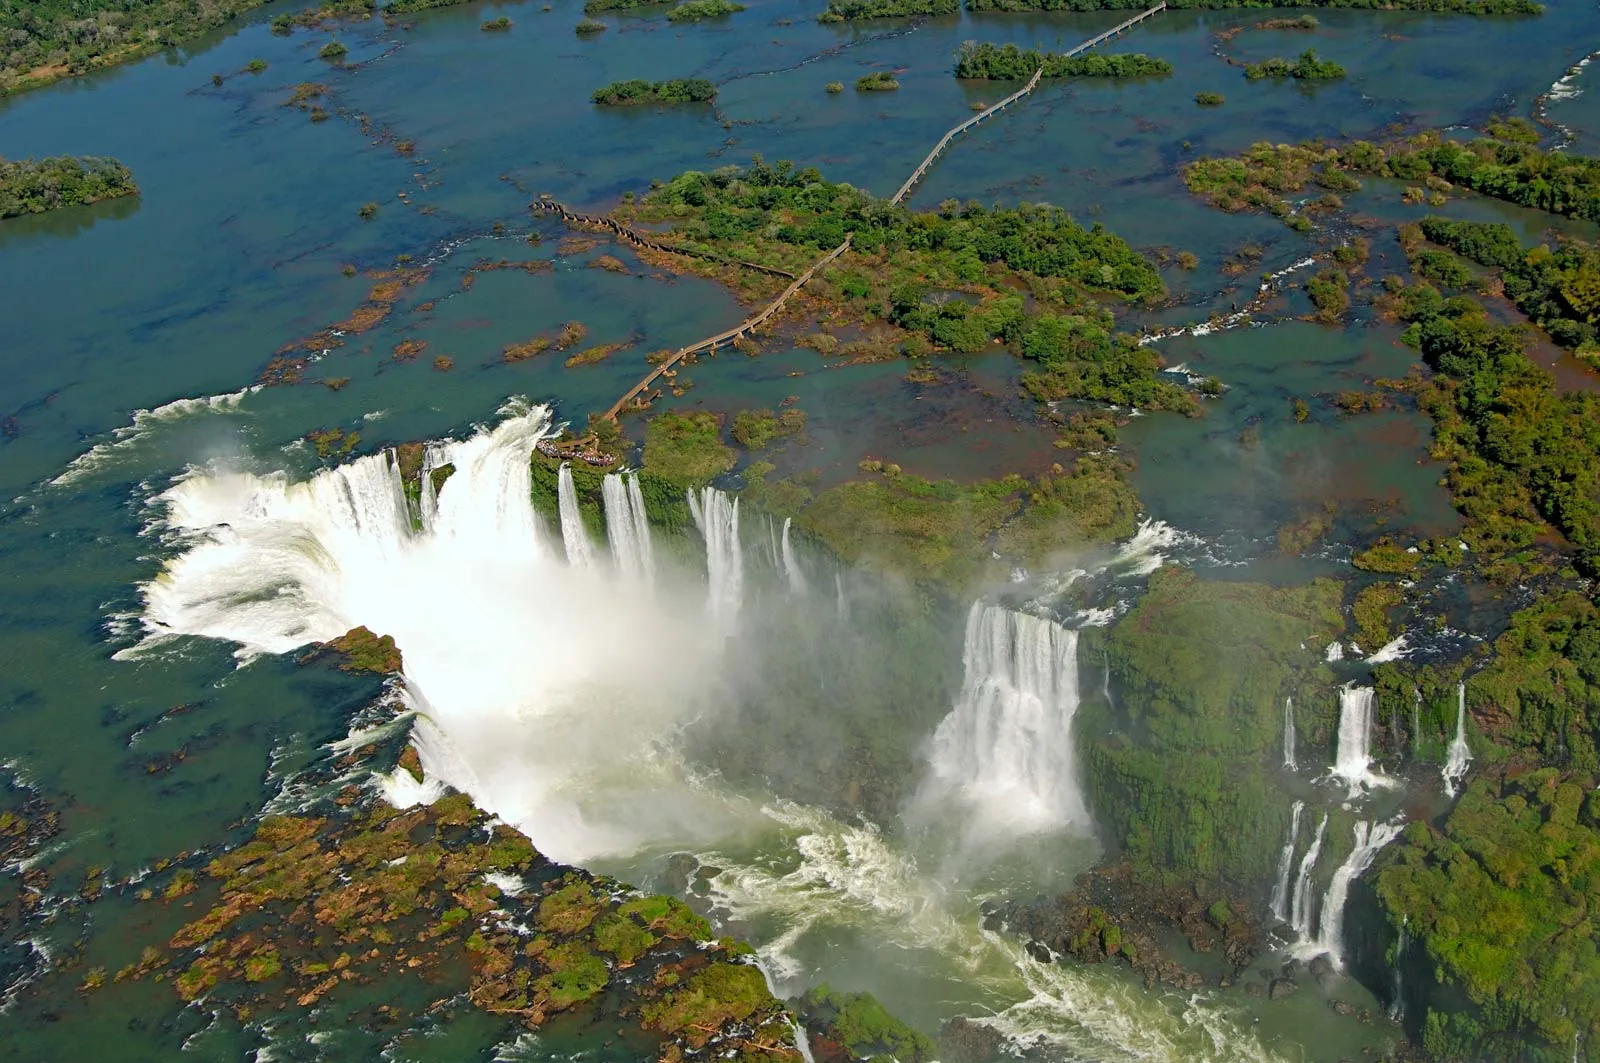Could you elaborate on how tourism around the Iguazu Falls is managed to protect the environment? Tourism around the Iguazu Falls is a double-edged sword; while it brings significant economic benefits to the region, it also poses challenges to environmental conservation. To manage this, strict regulations are in place to minimize human impact on the fragile ecosystem. Visitors are restricted to designated pathways and viewing platforms to prevent damage to vegetation and wildlife habitats. Educational programs for tourists raise awareness about the importance of preserving natural resources. Additionally, the implementation of eco-friendly infrastructure, such as waste recycling initiatives and water treatment systems, helps reduce the environmental footprint. Conservation efforts involve local communities and international organizations collaborating to maintain the natural beauty and biodiversity of the falls.  How might the landscape here change with the seasons? The landscape around the Iguazu Falls undergoes noticeable transformations with the changing seasons. During the rainy season, the river swells dramatically, increasing the volume and intensity of the falls, creating an even more powerful spectacle. The surrounding vegetation becomes even lusher, with flora thriving in the abundant moisture. In contrast, the dry season sees the water flow diminish, revealing more rock formations and altering the overall appearance of the falls. The surrounding forest may appear less dense, but this period can bring out different species of plants and animals, adapting to the seasonal changes. This cyclical transformation ensures a dynamic and ever-evolving natural landscape throughout the year. 